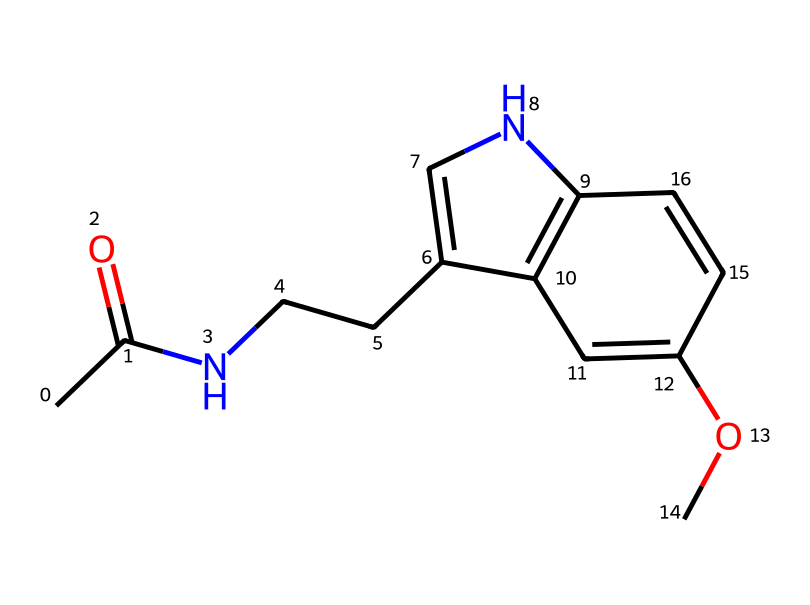What is the molecular formula of this chemical? To determine the molecular formula, we can count the number of each type of atom represented in the SMILES notation. Looking at the given SMILES, we identify 10 carbon (C) atoms, 12 hydrogen (H) atoms, 2 nitrogen (N) atoms, and 3 oxygen (O) atoms. Thus, the molecular formula can be constructed as C10H12N2O3.
Answer: C10H12N2O3 How many rings are present in the structure? By analyzing the structure, we can identify the presence of two cyclic components. The 'C1=CN' and the 'c2c1' sections indicate the formation of a ring structure in the molecule, confirming that there are two rings.
Answer: 2 What type of chemical compound is melatonin classified as? Based on its capabilities and structure, melatonin can be classified as an indoleamine. This classification stems from its tryptophan derivative and the indole ring found in its structure.
Answer: indoleamine How many oxygen atoms are in the structure? A quick count of the oxygen atoms in the molecular diagram reveals that two specific regions contain oxygen atoms: the -O- in the methoxy group and the carbonyl group. This confirms the presence of three oxygen atoms.
Answer: 3 What functional groups are present in this chemical? The analysis of the chemical structure allows us to identify several functional groups, including an amide group (C(=O)N) and a methoxy group (OCH3). These groups are important in determining the chemical behavior of melatonin.
Answer: amide, methoxy 